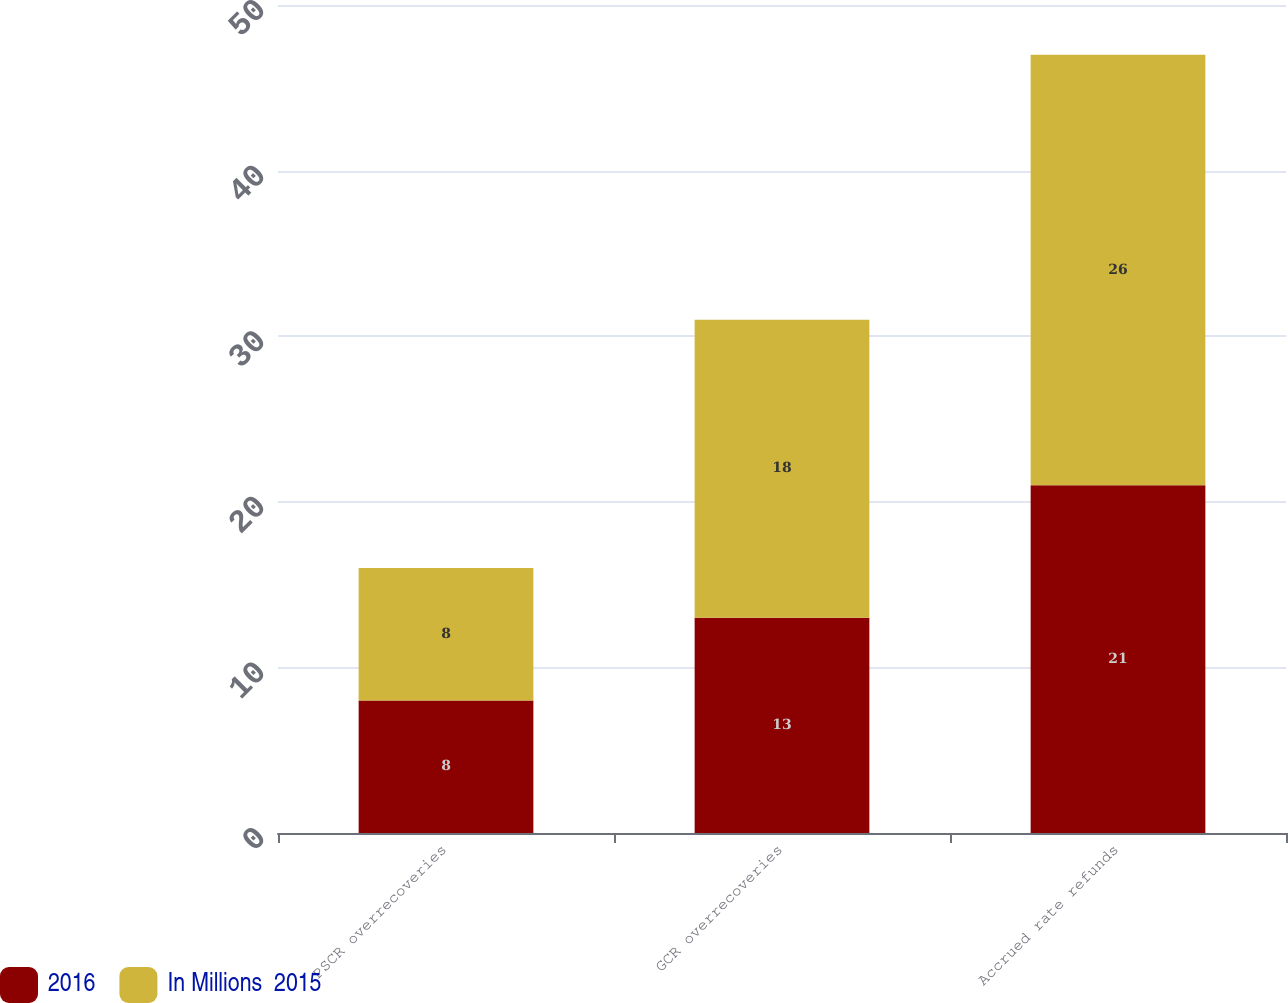<chart> <loc_0><loc_0><loc_500><loc_500><stacked_bar_chart><ecel><fcel>PSCR overrecoveries<fcel>GCR overrecoveries<fcel>Accrued rate refunds<nl><fcel>2016<fcel>8<fcel>13<fcel>21<nl><fcel>In Millions  2015<fcel>8<fcel>18<fcel>26<nl></chart> 